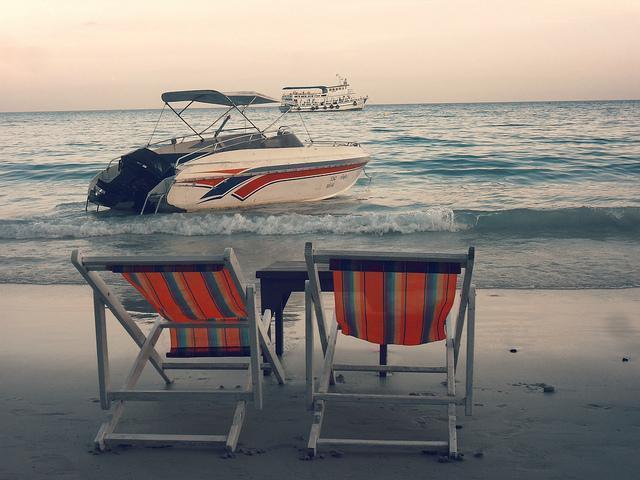What does the boat at the water's edge run on?
From the following set of four choices, select the accurate answer to respond to the question.
Options: Engine, rowing, sails, no propulsion. Rowing. 